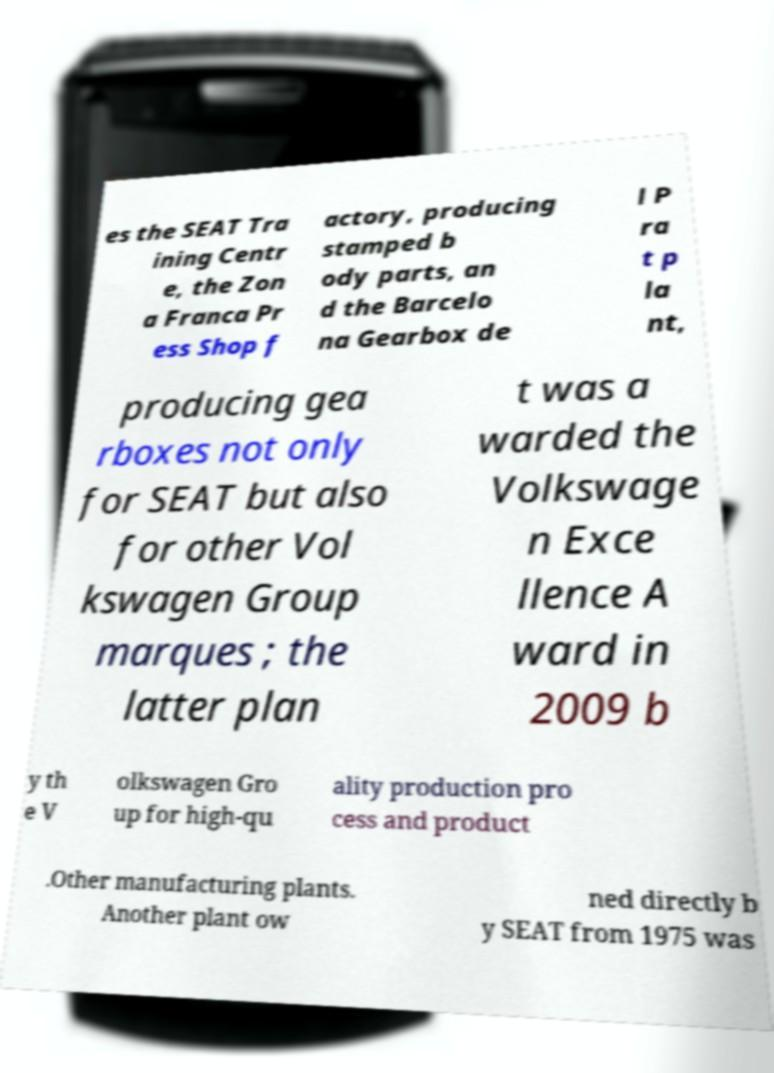For documentation purposes, I need the text within this image transcribed. Could you provide that? es the SEAT Tra ining Centr e, the Zon a Franca Pr ess Shop f actory, producing stamped b ody parts, an d the Barcelo na Gearbox de l P ra t p la nt, producing gea rboxes not only for SEAT but also for other Vol kswagen Group marques ; the latter plan t was a warded the Volkswage n Exce llence A ward in 2009 b y th e V olkswagen Gro up for high-qu ality production pro cess and product .Other manufacturing plants. Another plant ow ned directly b y SEAT from 1975 was 